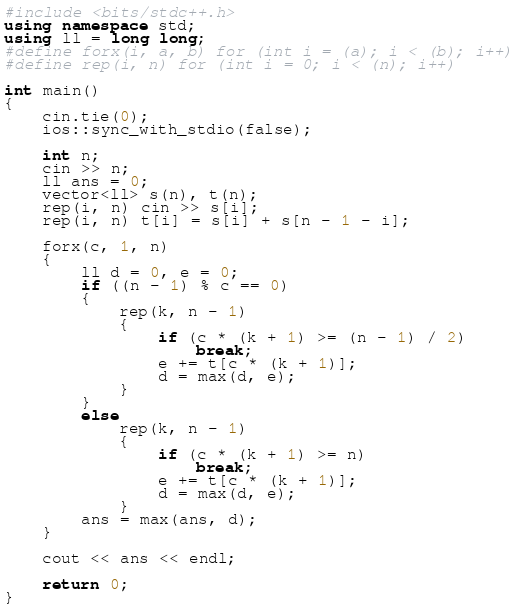<code> <loc_0><loc_0><loc_500><loc_500><_C++_>#include <bits/stdc++.h>
using namespace std;
using ll = long long;
#define forx(i, a, b) for (int i = (a); i < (b); i++)
#define rep(i, n) for (int i = 0; i < (n); i++)

int main()
{
    cin.tie(0);
    ios::sync_with_stdio(false);

    int n;
    cin >> n;
    ll ans = 0;
    vector<ll> s(n), t(n);
    rep(i, n) cin >> s[i];
    rep(i, n) t[i] = s[i] + s[n - 1 - i];

    forx(c, 1, n)
    {
        ll d = 0, e = 0;
        if ((n - 1) % c == 0)
        {
            rep(k, n - 1)
            {
                if (c * (k + 1) >= (n - 1) / 2)
                    break;
                e += t[c * (k + 1)];
                d = max(d, e);
            }
        }
        else
            rep(k, n - 1)
            {
                if (c * (k + 1) >= n)
                    break;
                e += t[c * (k + 1)];
                d = max(d, e);
            }
        ans = max(ans, d);
    }

    cout << ans << endl;

    return 0;
}</code> 